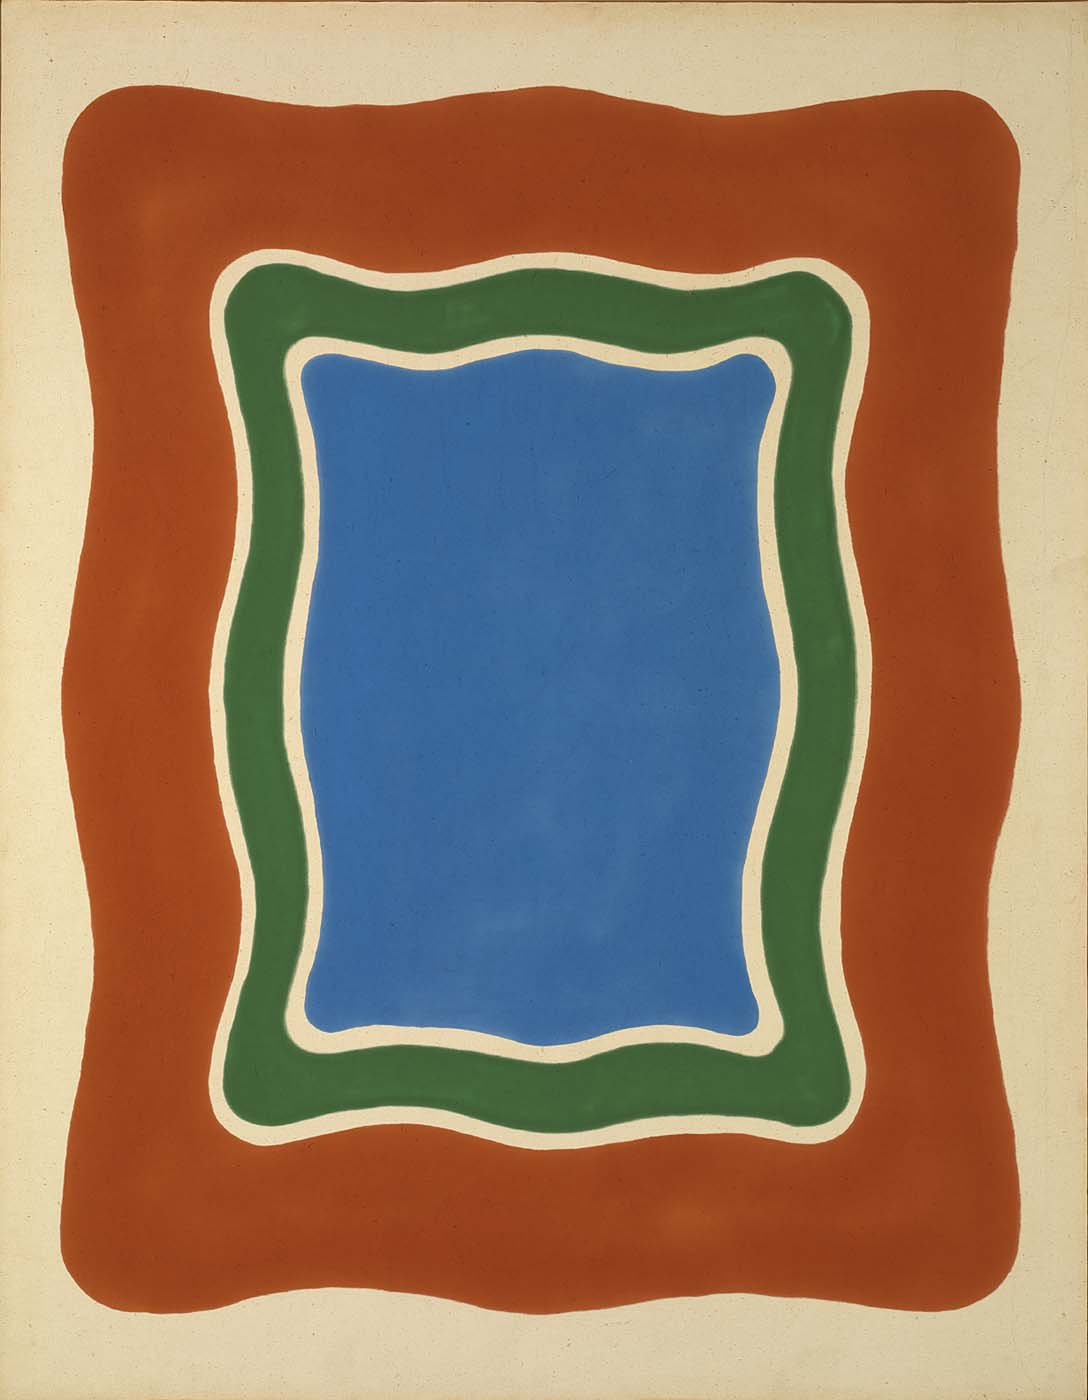Can you write a poetic description inspired by this image? In a canvas of whispers, a blue heart beats,
Bound by green veins, a contour sweet.
A red embrace, warm and bold,
In abstract loops, stories unfold.
Harmony in hues, silent and grand,
An abstract journey, crafted by hand.
Colors converse in a rhythmic trance,
Inviting the soul into a vibrant dance. 